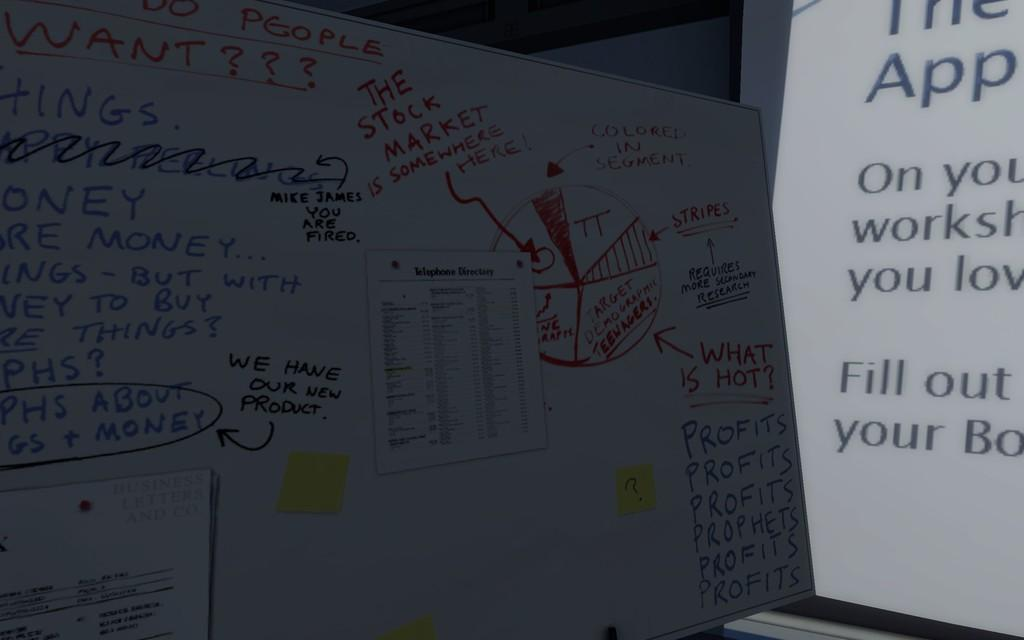<image>
Present a compact description of the photo's key features. the word app is on the white paper 